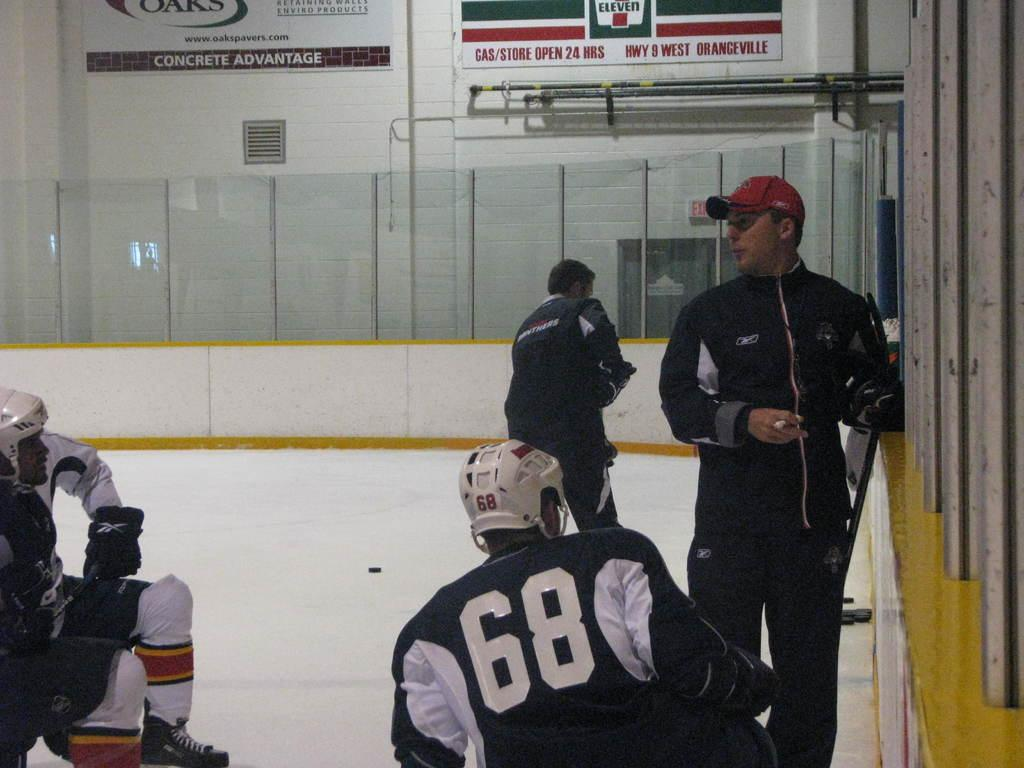<image>
Describe the image concisely. Hockey players are on the ice, geared up, in an arena with a large 7 Eleven poster on the wall. 